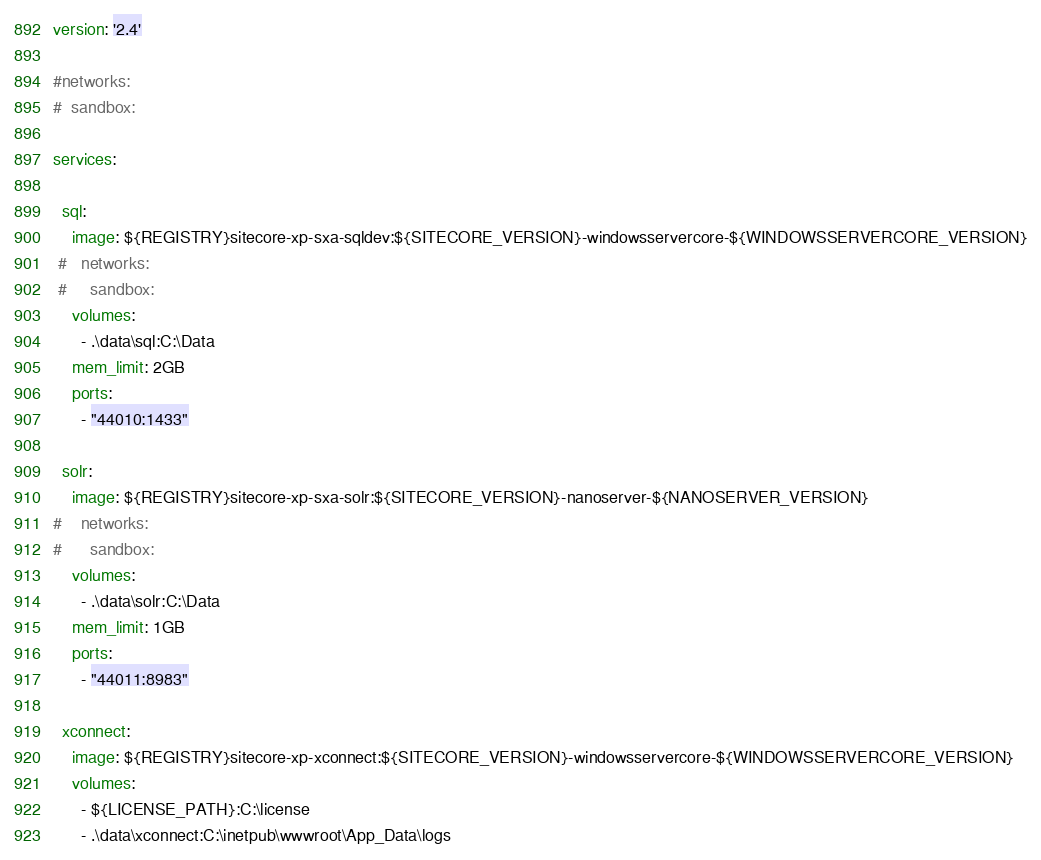Convert code to text. <code><loc_0><loc_0><loc_500><loc_500><_YAML_>version: '2.4'

#networks:
#  sandbox:

services:

  sql:
    image: ${REGISTRY}sitecore-xp-sxa-sqldev:${SITECORE_VERSION}-windowsservercore-${WINDOWSSERVERCORE_VERSION}
 #   networks:
 #     sandbox:
    volumes:
      - .\data\sql:C:\Data
    mem_limit: 2GB
    ports:
      - "44010:1433"

  solr:
    image: ${REGISTRY}sitecore-xp-sxa-solr:${SITECORE_VERSION}-nanoserver-${NANOSERVER_VERSION}
#    networks:
#      sandbox:
    volumes:
      - .\data\solr:C:\Data
    mem_limit: 1GB
    ports:
      - "44011:8983"

  xconnect:
    image: ${REGISTRY}sitecore-xp-xconnect:${SITECORE_VERSION}-windowsservercore-${WINDOWSSERVERCORE_VERSION}
    volumes:
      - ${LICENSE_PATH}:C:\license
      - .\data\xconnect:C:\inetpub\wwwroot\App_Data\logs</code> 